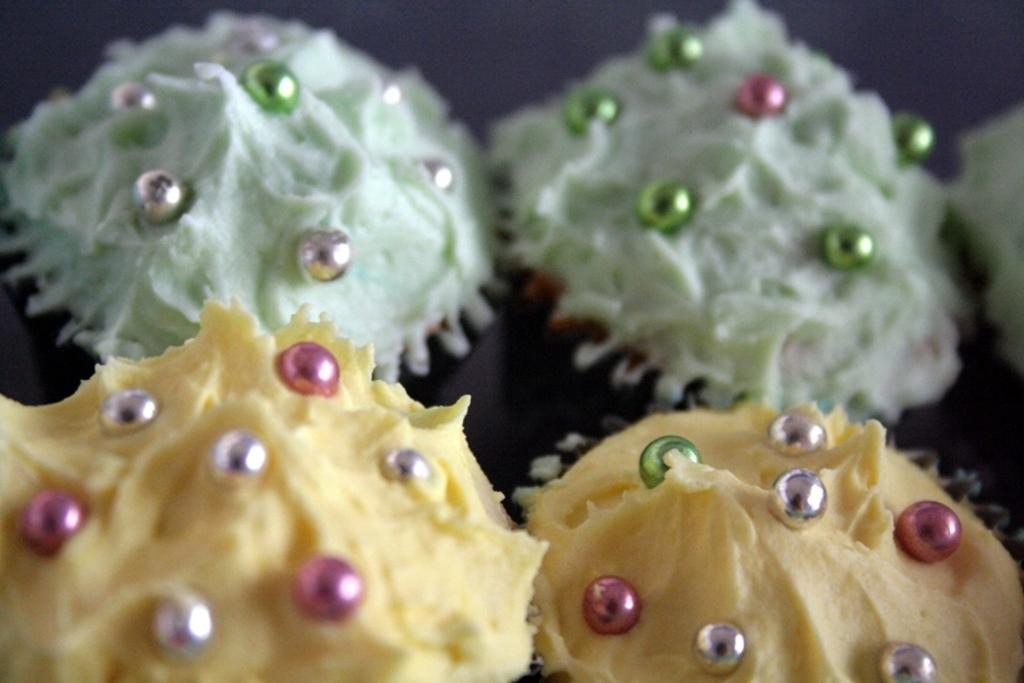What types of items can be seen in the image? There are food items in the image. Can you describe any specific features of the food items? There are circular objects on the food. What type of scarf is draped over the plate in the image? There is no scarf or plate present in the image. How does the ice interact with the food items in the image? There is no ice present in the image, so it cannot interact with the food items. 